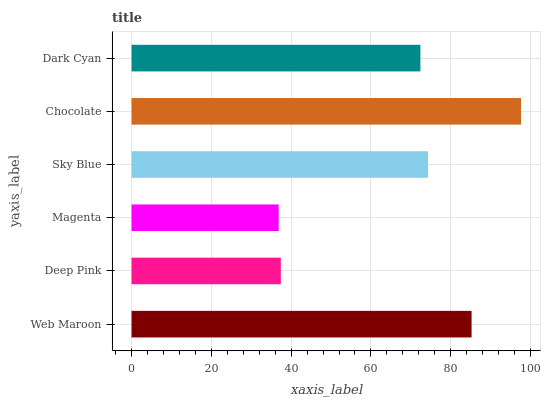Is Magenta the minimum?
Answer yes or no. Yes. Is Chocolate the maximum?
Answer yes or no. Yes. Is Deep Pink the minimum?
Answer yes or no. No. Is Deep Pink the maximum?
Answer yes or no. No. Is Web Maroon greater than Deep Pink?
Answer yes or no. Yes. Is Deep Pink less than Web Maroon?
Answer yes or no. Yes. Is Deep Pink greater than Web Maroon?
Answer yes or no. No. Is Web Maroon less than Deep Pink?
Answer yes or no. No. Is Sky Blue the high median?
Answer yes or no. Yes. Is Dark Cyan the low median?
Answer yes or no. Yes. Is Chocolate the high median?
Answer yes or no. No. Is Deep Pink the low median?
Answer yes or no. No. 